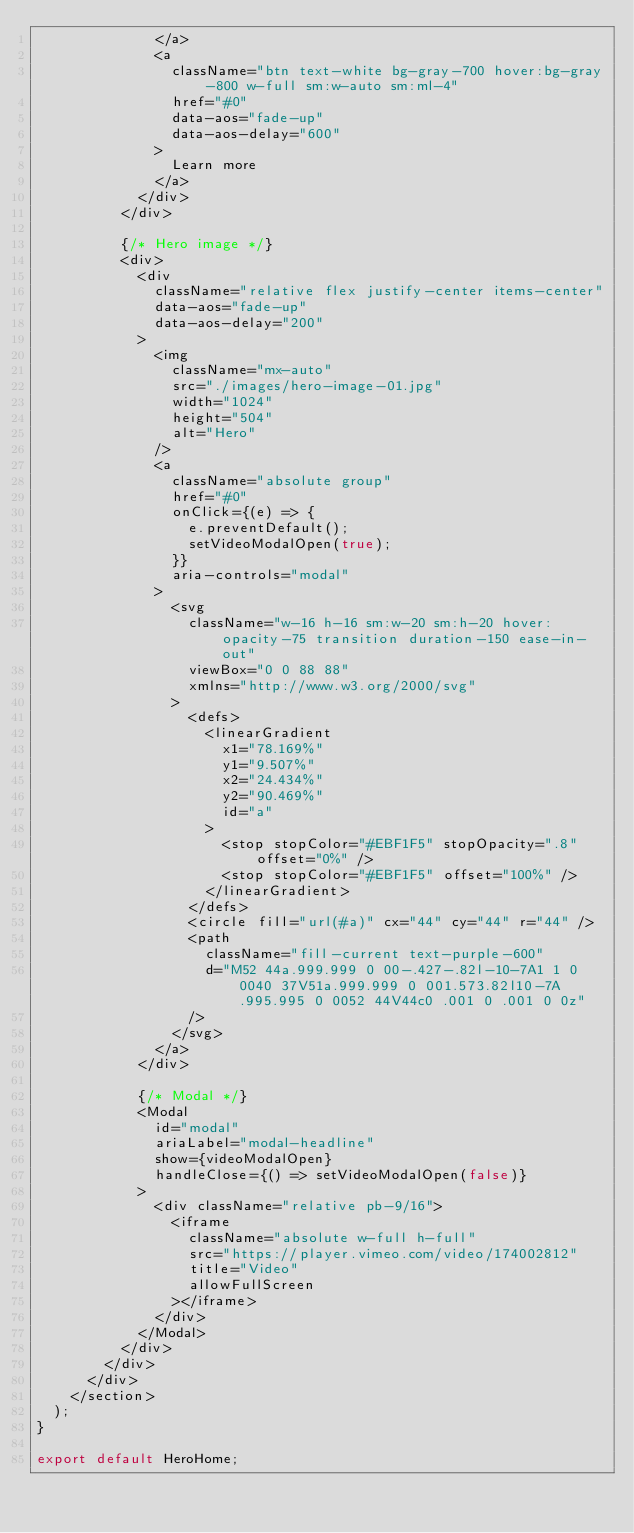Convert code to text. <code><loc_0><loc_0><loc_500><loc_500><_JavaScript_>              </a>
              <a
                className="btn text-white bg-gray-700 hover:bg-gray-800 w-full sm:w-auto sm:ml-4"
                href="#0"
                data-aos="fade-up"
                data-aos-delay="600"
              >
                Learn more
              </a>
            </div>
          </div>

          {/* Hero image */}
          <div>
            <div
              className="relative flex justify-center items-center"
              data-aos="fade-up"
              data-aos-delay="200"
            >
              <img
                className="mx-auto"
                src="./images/hero-image-01.jpg"
                width="1024"
                height="504"
                alt="Hero"
              />
              <a
                className="absolute group"
                href="#0"
                onClick={(e) => {
                  e.preventDefault();
                  setVideoModalOpen(true);
                }}
                aria-controls="modal"
              >
                <svg
                  className="w-16 h-16 sm:w-20 sm:h-20 hover:opacity-75 transition duration-150 ease-in-out"
                  viewBox="0 0 88 88"
                  xmlns="http://www.w3.org/2000/svg"
                >
                  <defs>
                    <linearGradient
                      x1="78.169%"
                      y1="9.507%"
                      x2="24.434%"
                      y2="90.469%"
                      id="a"
                    >
                      <stop stopColor="#EBF1F5" stopOpacity=".8" offset="0%" />
                      <stop stopColor="#EBF1F5" offset="100%" />
                    </linearGradient>
                  </defs>
                  <circle fill="url(#a)" cx="44" cy="44" r="44" />
                  <path
                    className="fill-current text-purple-600"
                    d="M52 44a.999.999 0 00-.427-.82l-10-7A1 1 0 0040 37V51a.999.999 0 001.573.82l10-7A.995.995 0 0052 44V44c0 .001 0 .001 0 0z"
                  />
                </svg>
              </a>
            </div>

            {/* Modal */}
            <Modal
              id="modal"
              ariaLabel="modal-headline"
              show={videoModalOpen}
              handleClose={() => setVideoModalOpen(false)}
            >
              <div className="relative pb-9/16">
                <iframe
                  className="absolute w-full h-full"
                  src="https://player.vimeo.com/video/174002812"
                  title="Video"
                  allowFullScreen
                ></iframe>
              </div>
            </Modal>
          </div>
        </div>
      </div>
    </section>
  );
}

export default HeroHome;
</code> 